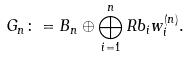<formula> <loc_0><loc_0><loc_500><loc_500>G _ { n } \colon = B _ { n } \oplus \bigoplus _ { i = 1 } ^ { n } R b _ { i } w _ { i } ^ { ( n ) } .</formula> 